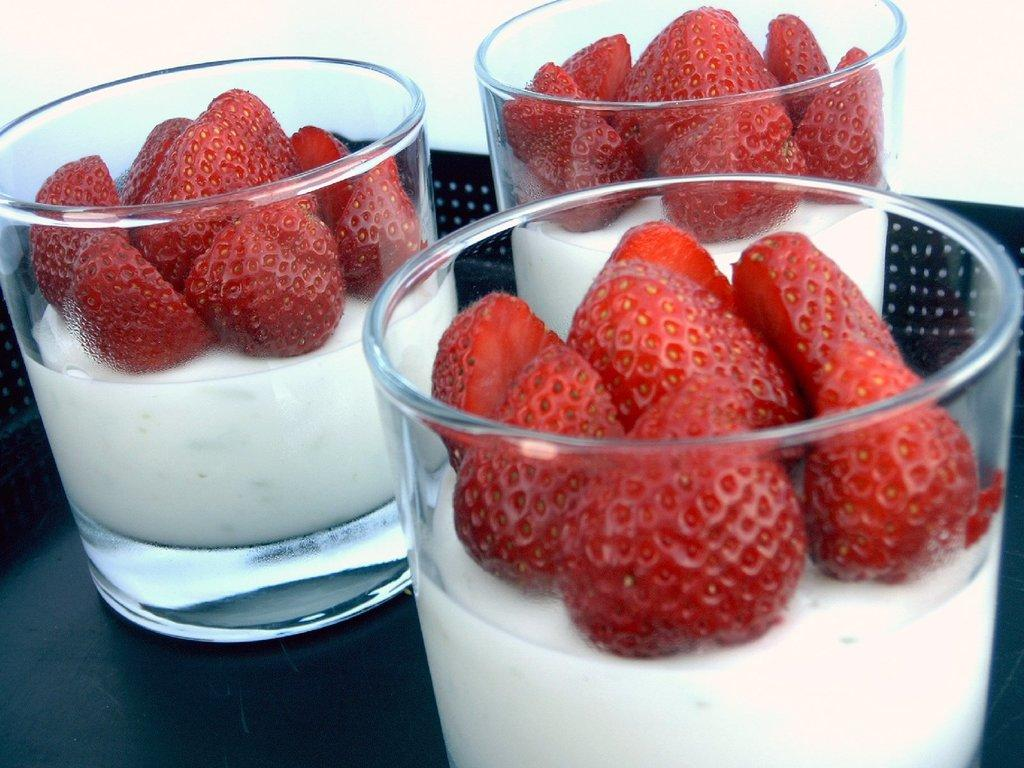What objects are in the image that people might use to consume a drink? There are glasses in the image that people might use to consume a drink. What fruit is visible in the image? There are strawberries in the image. What is the drink in the image contained in? The drink is in the image, but the specific container is not mentioned. However, since there are glasses in the image, it is likely that the drink is in one of those glasses. What color is the surface on which the glasses are placed? The glasses are placed on a black surface. What type of joke is being told on the stage in the image? There is no stage or joke present in the image; it features glasses, strawberries, a drink, and a black surface. 